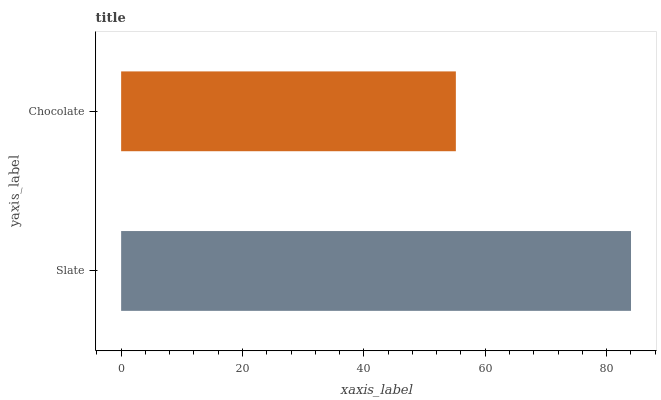Is Chocolate the minimum?
Answer yes or no. Yes. Is Slate the maximum?
Answer yes or no. Yes. Is Chocolate the maximum?
Answer yes or no. No. Is Slate greater than Chocolate?
Answer yes or no. Yes. Is Chocolate less than Slate?
Answer yes or no. Yes. Is Chocolate greater than Slate?
Answer yes or no. No. Is Slate less than Chocolate?
Answer yes or no. No. Is Slate the high median?
Answer yes or no. Yes. Is Chocolate the low median?
Answer yes or no. Yes. Is Chocolate the high median?
Answer yes or no. No. Is Slate the low median?
Answer yes or no. No. 